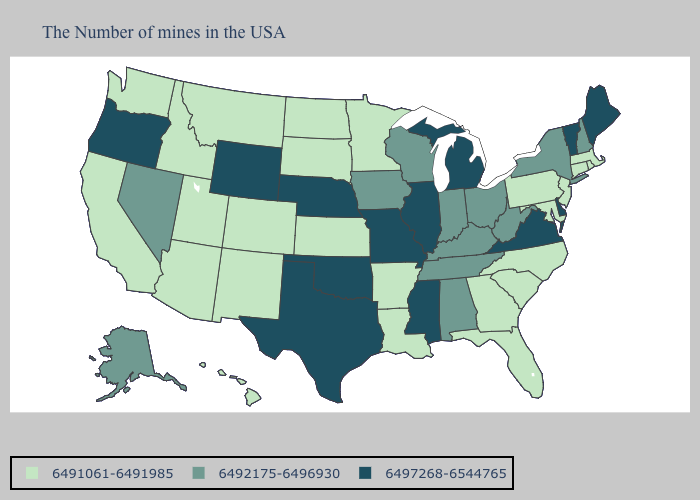Name the states that have a value in the range 6492175-6496930?
Answer briefly. New Hampshire, New York, West Virginia, Ohio, Kentucky, Indiana, Alabama, Tennessee, Wisconsin, Iowa, Nevada, Alaska. Among the states that border West Virginia , does Virginia have the lowest value?
Concise answer only. No. Among the states that border Maryland , which have the lowest value?
Short answer required. Pennsylvania. Does Iowa have a higher value than Montana?
Answer briefly. Yes. Among the states that border Colorado , which have the lowest value?
Keep it brief. Kansas, New Mexico, Utah, Arizona. What is the value of Montana?
Concise answer only. 6491061-6491985. Does Vermont have the same value as Delaware?
Write a very short answer. Yes. Which states have the lowest value in the USA?
Be succinct. Massachusetts, Rhode Island, Connecticut, New Jersey, Maryland, Pennsylvania, North Carolina, South Carolina, Florida, Georgia, Louisiana, Arkansas, Minnesota, Kansas, South Dakota, North Dakota, Colorado, New Mexico, Utah, Montana, Arizona, Idaho, California, Washington, Hawaii. Does the map have missing data?
Give a very brief answer. No. Does the first symbol in the legend represent the smallest category?
Short answer required. Yes. Does Minnesota have a higher value than New Mexico?
Give a very brief answer. No. Which states have the lowest value in the Northeast?
Give a very brief answer. Massachusetts, Rhode Island, Connecticut, New Jersey, Pennsylvania. Does Florida have the lowest value in the USA?
Be succinct. Yes. 